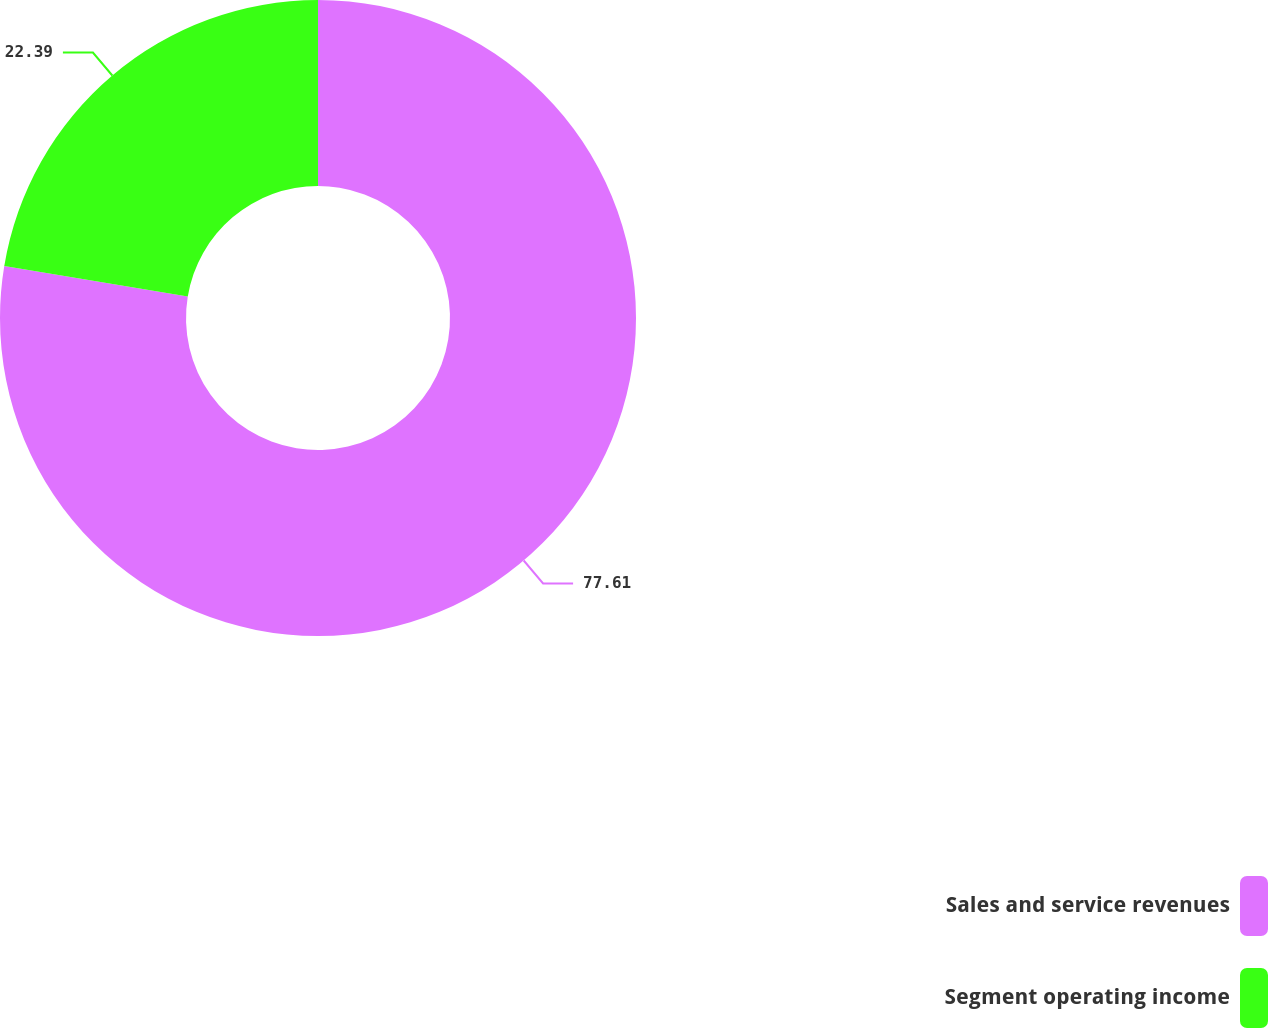Convert chart to OTSL. <chart><loc_0><loc_0><loc_500><loc_500><pie_chart><fcel>Sales and service revenues<fcel>Segment operating income<nl><fcel>77.61%<fcel>22.39%<nl></chart> 